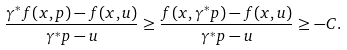<formula> <loc_0><loc_0><loc_500><loc_500>\frac { \gamma ^ { * } f ( x , p ) - f ( x , u ) } { \gamma ^ { * } p - u } \geq \frac { f ( x , \gamma ^ { * } p ) - f ( x , u ) } { \gamma ^ { * } p - u } \geq - C .</formula> 